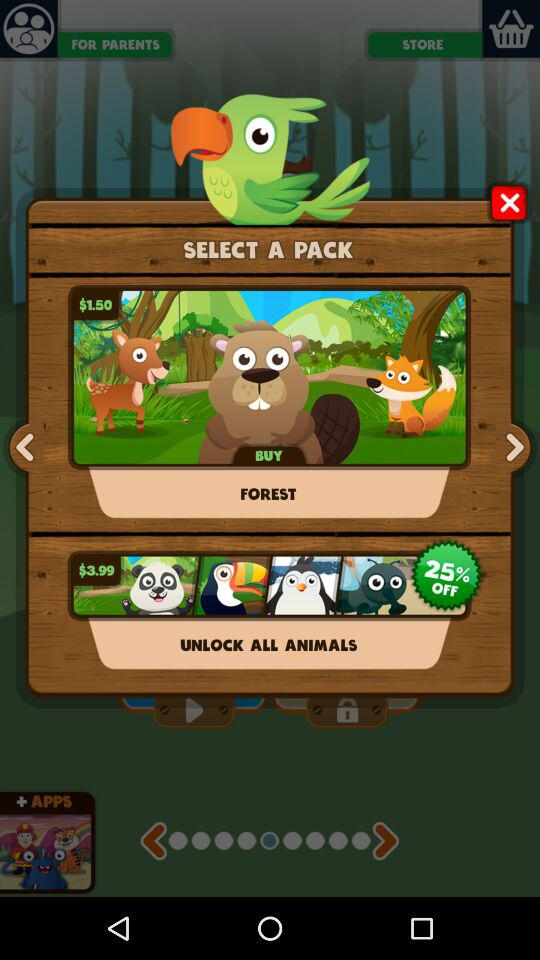How many animals are featured in the panda bear, toucan, penguin, and penguin pack?
Answer the question using a single word or phrase. 4 